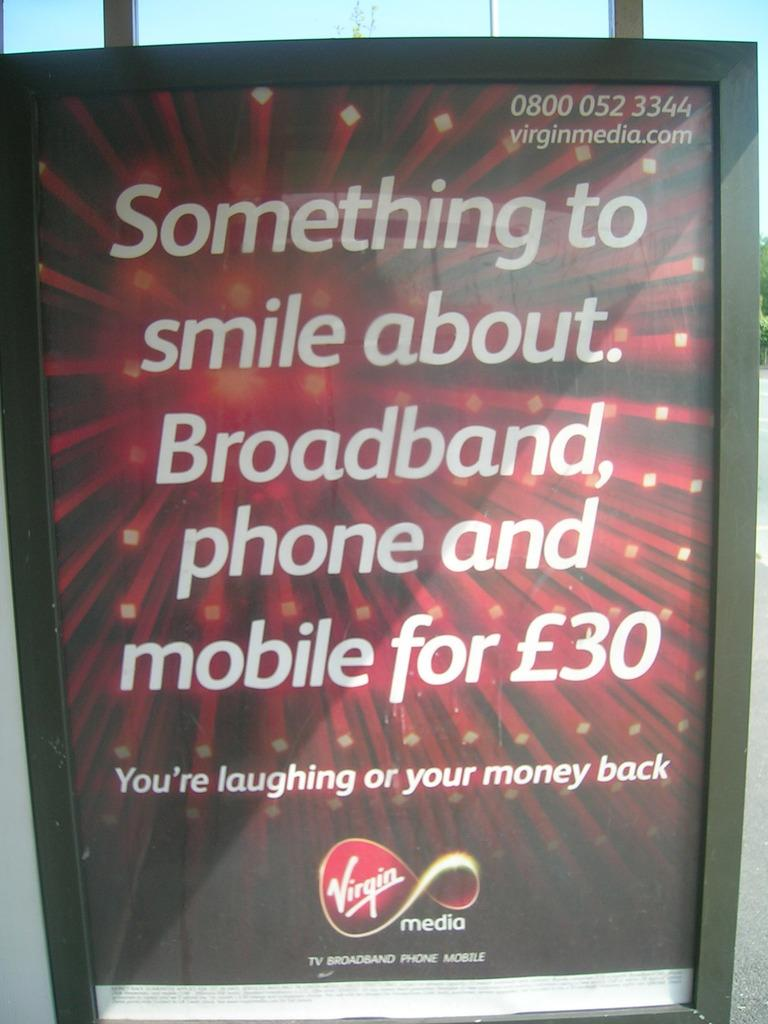What is the main object in the image? There is a digital screen in the image. What can be seen on the digital screen? There is text on the digital screen. What is the color of the background in the image? The background color of the image is red. Can you see a camera capturing the image of the digital screen? There is no camera visible in the image; it only shows the digital screen with text and a red background. 